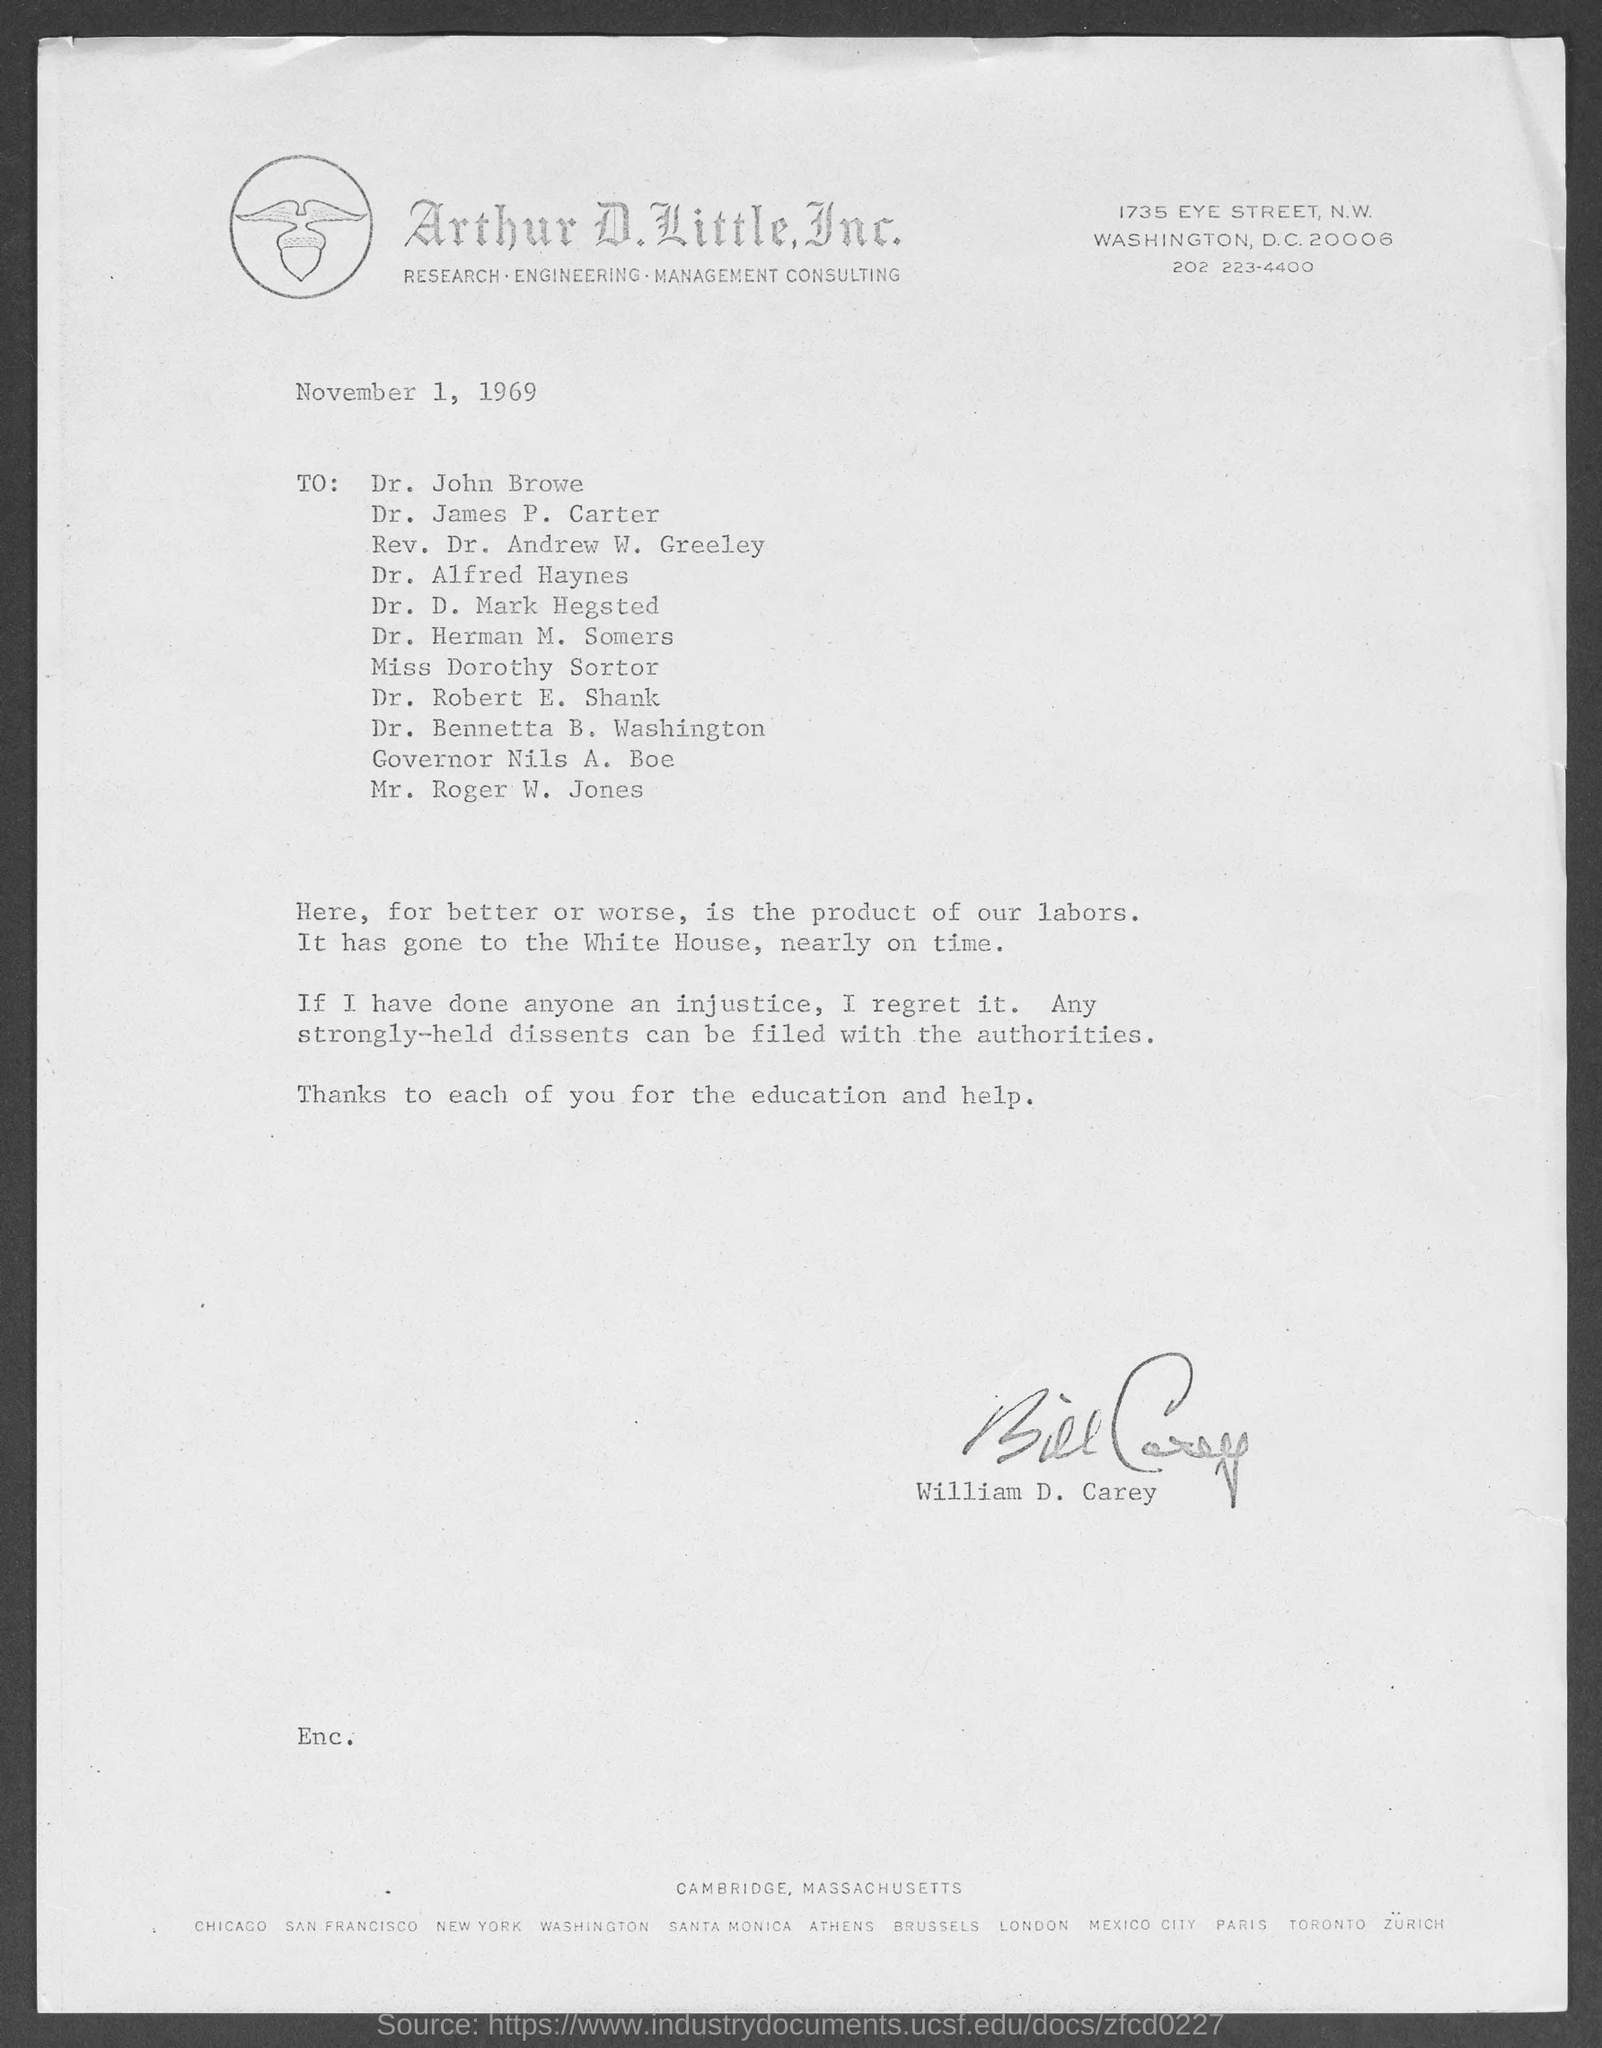Give some essential details in this illustration. The date above is November 1, 1969. William D. Carey wrote the memorandum. Arthur D. Little, Inc. is located at 1735 Eye Street. 